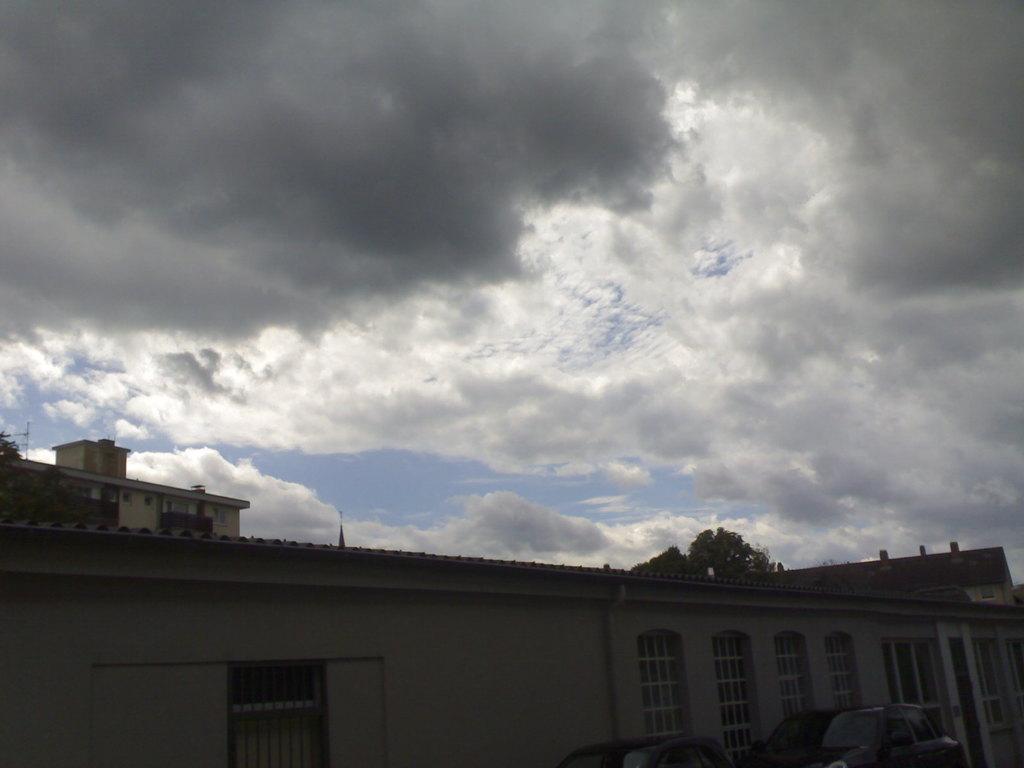Can you describe this image briefly? In the image we can see there is a building and there are trees and there is a cloudy sky. 